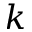Convert formula to latex. <formula><loc_0><loc_0><loc_500><loc_500>k</formula> 